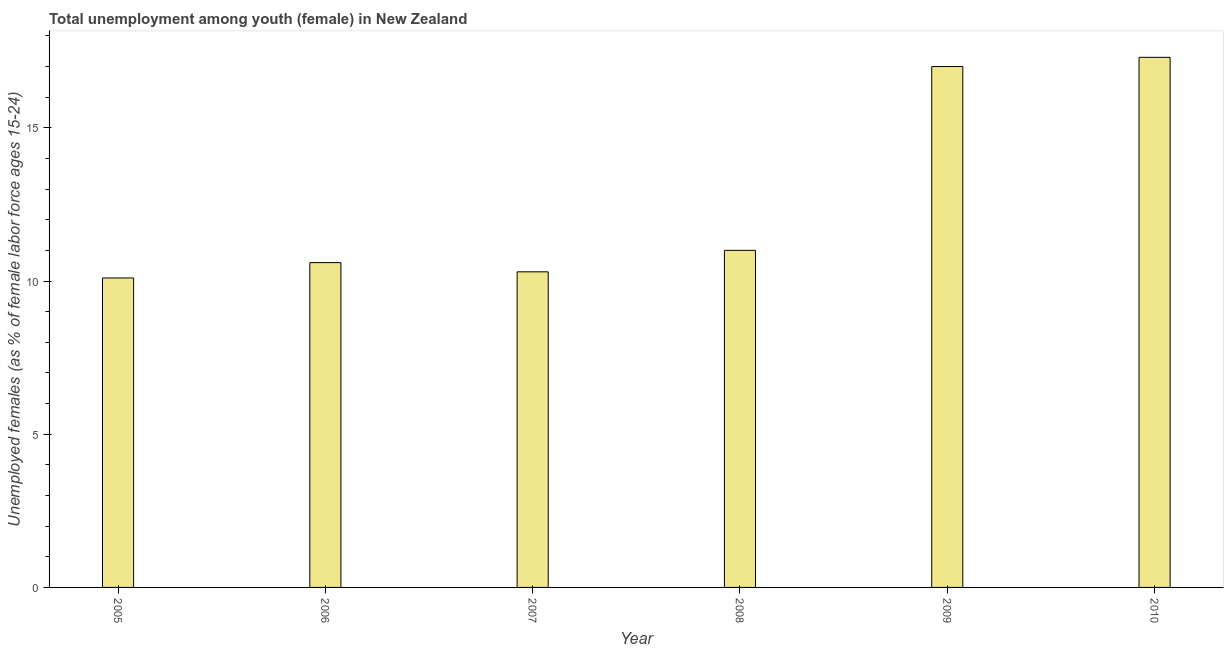Does the graph contain any zero values?
Provide a short and direct response. No. Does the graph contain grids?
Keep it short and to the point. No. What is the title of the graph?
Keep it short and to the point. Total unemployment among youth (female) in New Zealand. What is the label or title of the Y-axis?
Offer a very short reply. Unemployed females (as % of female labor force ages 15-24). What is the unemployed female youth population in 2010?
Keep it short and to the point. 17.3. Across all years, what is the maximum unemployed female youth population?
Give a very brief answer. 17.3. Across all years, what is the minimum unemployed female youth population?
Make the answer very short. 10.1. What is the sum of the unemployed female youth population?
Offer a terse response. 76.3. What is the average unemployed female youth population per year?
Make the answer very short. 12.72. What is the median unemployed female youth population?
Provide a succinct answer. 10.8. What is the ratio of the unemployed female youth population in 2005 to that in 2008?
Your answer should be compact. 0.92. Is the difference between the unemployed female youth population in 2009 and 2010 greater than the difference between any two years?
Give a very brief answer. No. What is the difference between the highest and the second highest unemployed female youth population?
Your response must be concise. 0.3. What is the difference between the highest and the lowest unemployed female youth population?
Make the answer very short. 7.2. In how many years, is the unemployed female youth population greater than the average unemployed female youth population taken over all years?
Ensure brevity in your answer.  2. How many bars are there?
Make the answer very short. 6. What is the Unemployed females (as % of female labor force ages 15-24) in 2005?
Your answer should be compact. 10.1. What is the Unemployed females (as % of female labor force ages 15-24) in 2006?
Ensure brevity in your answer.  10.6. What is the Unemployed females (as % of female labor force ages 15-24) of 2007?
Provide a short and direct response. 10.3. What is the Unemployed females (as % of female labor force ages 15-24) in 2010?
Make the answer very short. 17.3. What is the difference between the Unemployed females (as % of female labor force ages 15-24) in 2005 and 2006?
Give a very brief answer. -0.5. What is the difference between the Unemployed females (as % of female labor force ages 15-24) in 2005 and 2007?
Your answer should be compact. -0.2. What is the difference between the Unemployed females (as % of female labor force ages 15-24) in 2005 and 2008?
Offer a terse response. -0.9. What is the difference between the Unemployed females (as % of female labor force ages 15-24) in 2005 and 2009?
Your answer should be compact. -6.9. What is the difference between the Unemployed females (as % of female labor force ages 15-24) in 2006 and 2007?
Make the answer very short. 0.3. What is the difference between the Unemployed females (as % of female labor force ages 15-24) in 2007 and 2008?
Keep it short and to the point. -0.7. What is the difference between the Unemployed females (as % of female labor force ages 15-24) in 2007 and 2009?
Your answer should be very brief. -6.7. What is the ratio of the Unemployed females (as % of female labor force ages 15-24) in 2005 to that in 2006?
Provide a succinct answer. 0.95. What is the ratio of the Unemployed females (as % of female labor force ages 15-24) in 2005 to that in 2008?
Give a very brief answer. 0.92. What is the ratio of the Unemployed females (as % of female labor force ages 15-24) in 2005 to that in 2009?
Provide a succinct answer. 0.59. What is the ratio of the Unemployed females (as % of female labor force ages 15-24) in 2005 to that in 2010?
Make the answer very short. 0.58. What is the ratio of the Unemployed females (as % of female labor force ages 15-24) in 2006 to that in 2007?
Your response must be concise. 1.03. What is the ratio of the Unemployed females (as % of female labor force ages 15-24) in 2006 to that in 2009?
Give a very brief answer. 0.62. What is the ratio of the Unemployed females (as % of female labor force ages 15-24) in 2006 to that in 2010?
Offer a very short reply. 0.61. What is the ratio of the Unemployed females (as % of female labor force ages 15-24) in 2007 to that in 2008?
Your response must be concise. 0.94. What is the ratio of the Unemployed females (as % of female labor force ages 15-24) in 2007 to that in 2009?
Provide a succinct answer. 0.61. What is the ratio of the Unemployed females (as % of female labor force ages 15-24) in 2007 to that in 2010?
Your response must be concise. 0.59. What is the ratio of the Unemployed females (as % of female labor force ages 15-24) in 2008 to that in 2009?
Your response must be concise. 0.65. What is the ratio of the Unemployed females (as % of female labor force ages 15-24) in 2008 to that in 2010?
Give a very brief answer. 0.64. What is the ratio of the Unemployed females (as % of female labor force ages 15-24) in 2009 to that in 2010?
Provide a succinct answer. 0.98. 